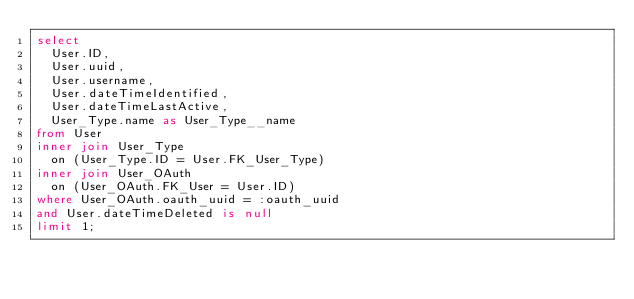<code> <loc_0><loc_0><loc_500><loc_500><_SQL_>select
	User.ID,
	User.uuid,
	User.username,
	User.dateTimeIdentified,
	User.dateTimeLastActive,
	User_Type.name as User_Type__name
from User
inner join User_Type
	on (User_Type.ID = User.FK_User_Type)
inner join User_OAuth
	on (User_OAuth.FK_User = User.ID)
where User_OAuth.oauth_uuid = :oauth_uuid
and User.dateTimeDeleted is null
limit 1;</code> 